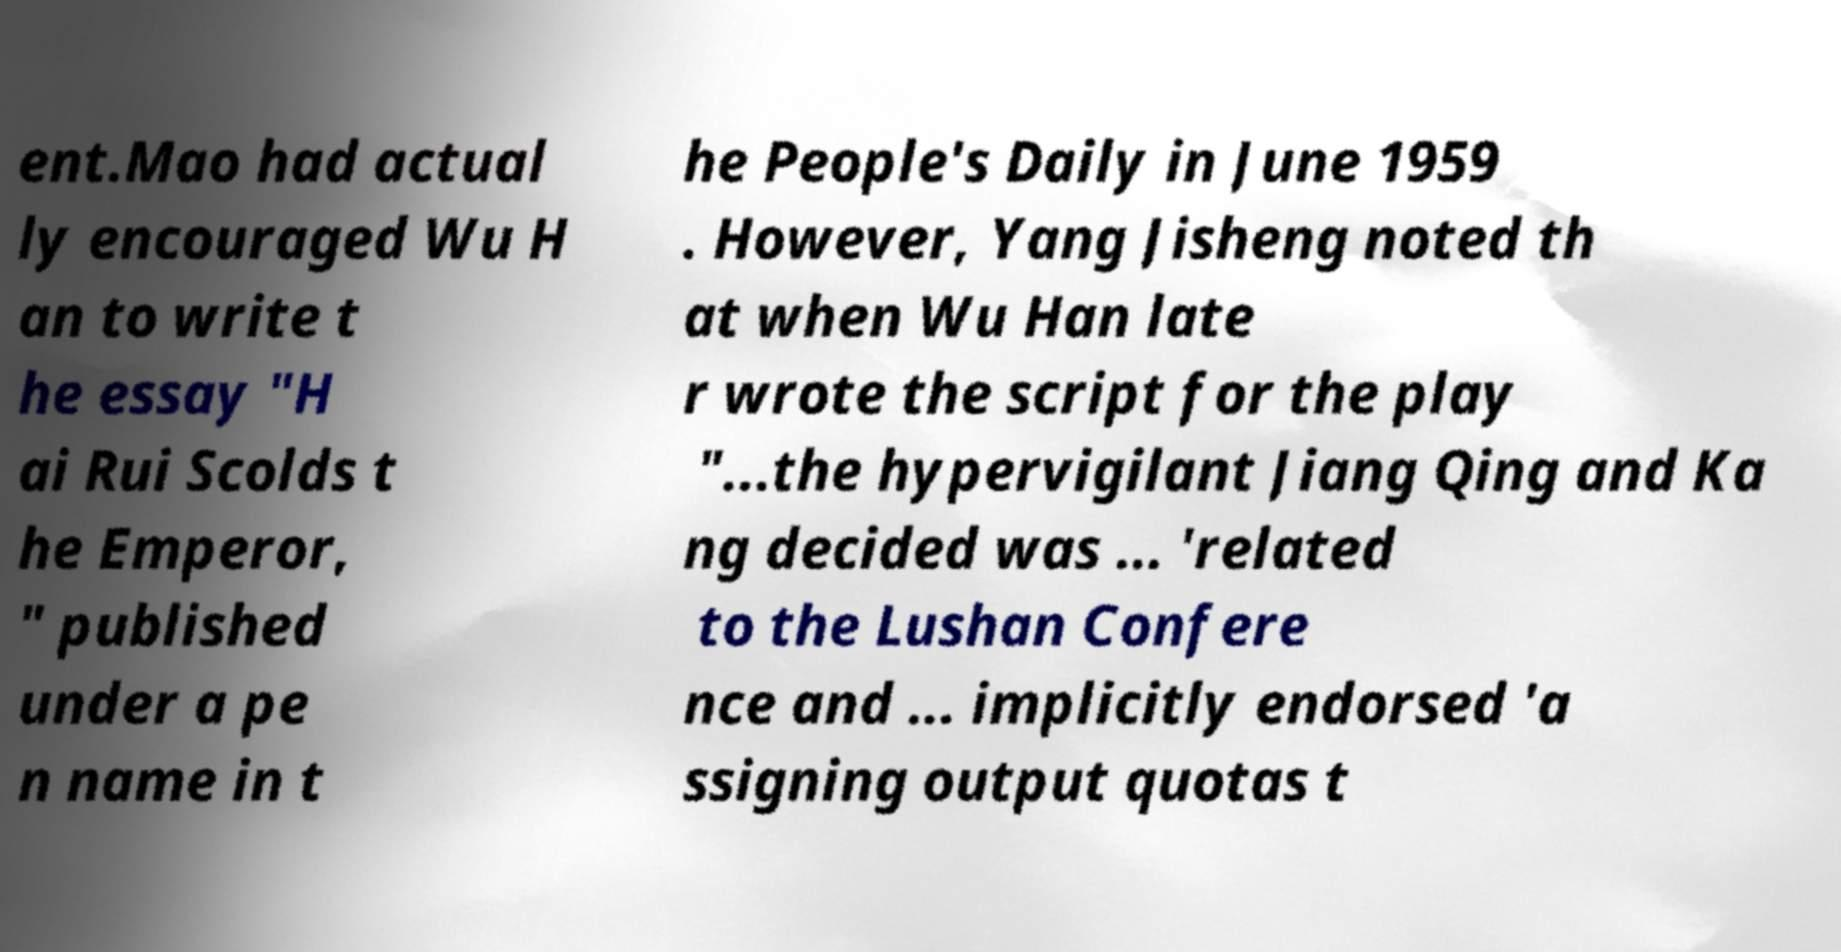Could you assist in decoding the text presented in this image and type it out clearly? ent.Mao had actual ly encouraged Wu H an to write t he essay "H ai Rui Scolds t he Emperor, " published under a pe n name in t he People's Daily in June 1959 . However, Yang Jisheng noted th at when Wu Han late r wrote the script for the play "...the hypervigilant Jiang Qing and Ka ng decided was ... 'related to the Lushan Confere nce and ... implicitly endorsed 'a ssigning output quotas t 